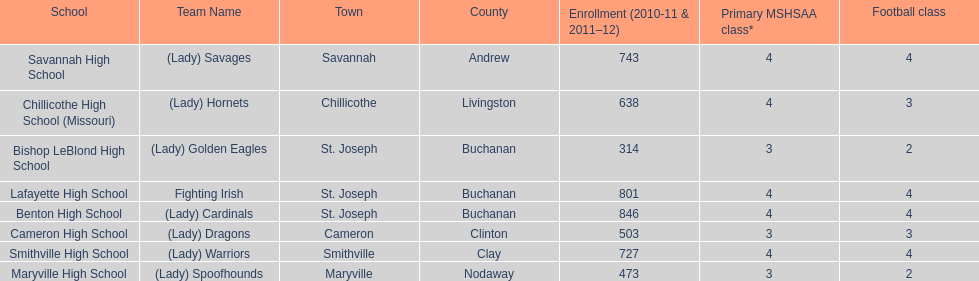What school has 3 football classes but only has 638 student enrollment? Chillicothe High School (Missouri). 